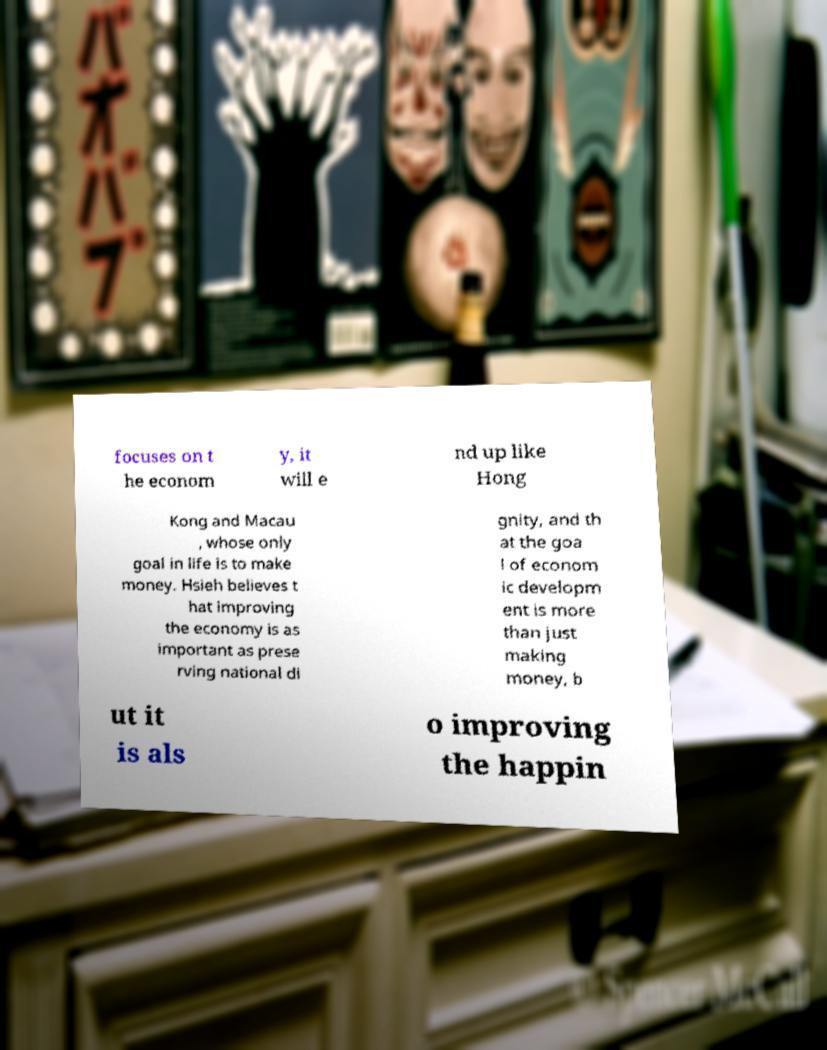What messages or text are displayed in this image? I need them in a readable, typed format. focuses on t he econom y, it will e nd up like Hong Kong and Macau , whose only goal in life is to make money. Hsieh believes t hat improving the economy is as important as prese rving national di gnity, and th at the goa l of econom ic developm ent is more than just making money, b ut it is als o improving the happin 